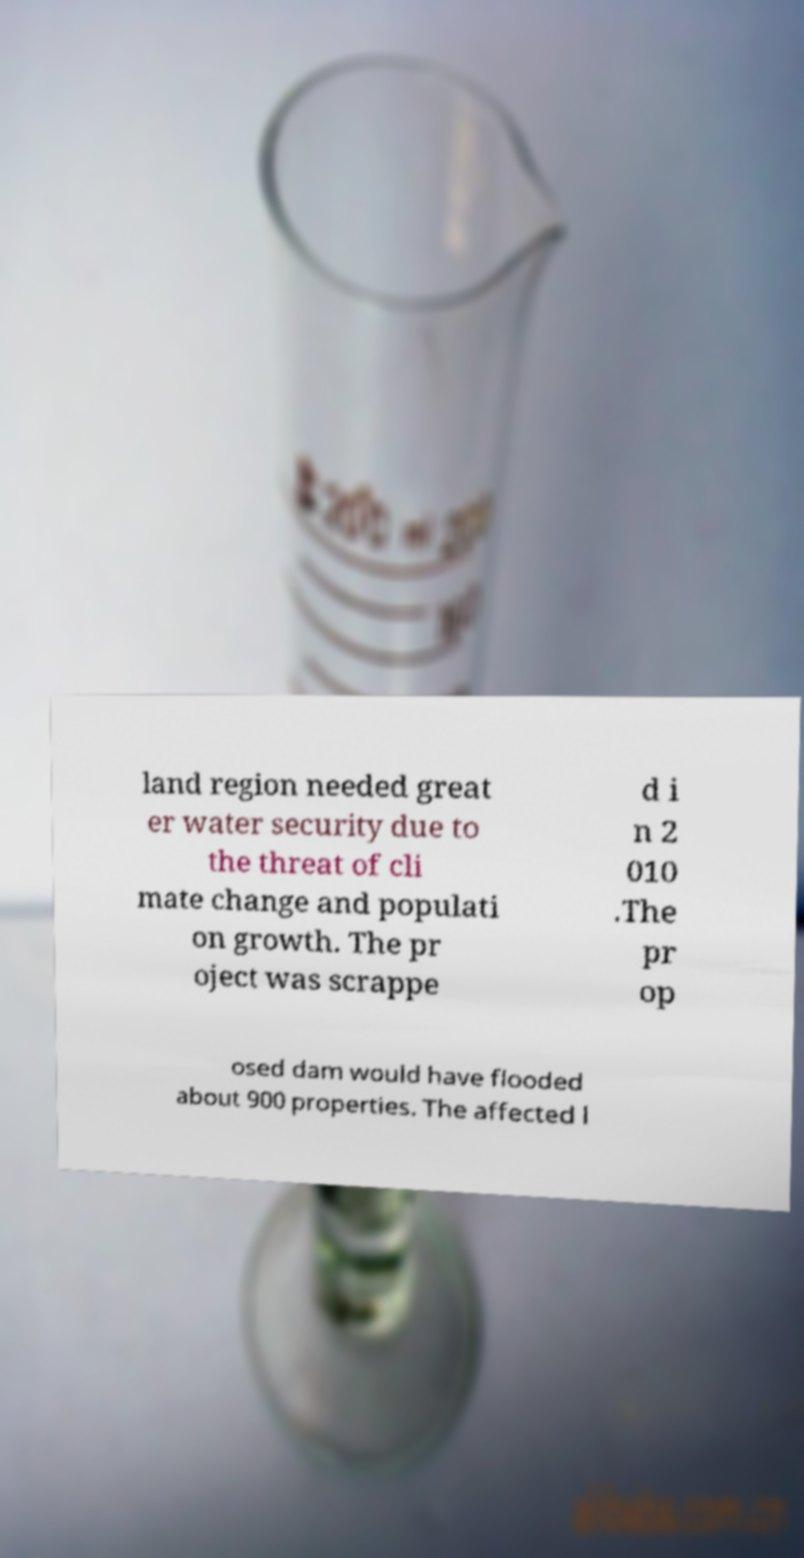Please read and relay the text visible in this image. What does it say? land region needed great er water security due to the threat of cli mate change and populati on growth. The pr oject was scrappe d i n 2 010 .The pr op osed dam would have flooded about 900 properties. The affected l 